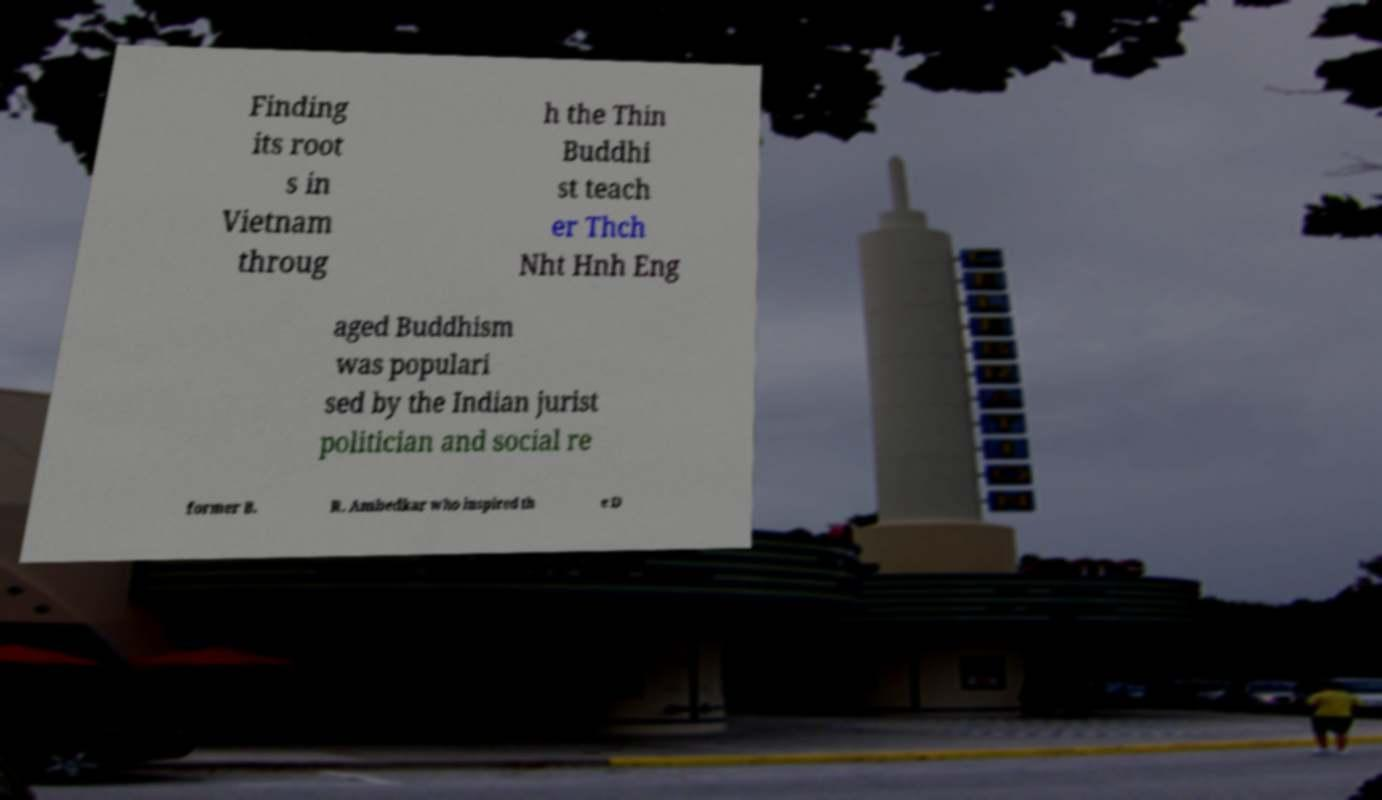Could you extract and type out the text from this image? Finding its root s in Vietnam throug h the Thin Buddhi st teach er Thch Nht Hnh Eng aged Buddhism was populari sed by the Indian jurist politician and social re former B. R. Ambedkar who inspired th e D 